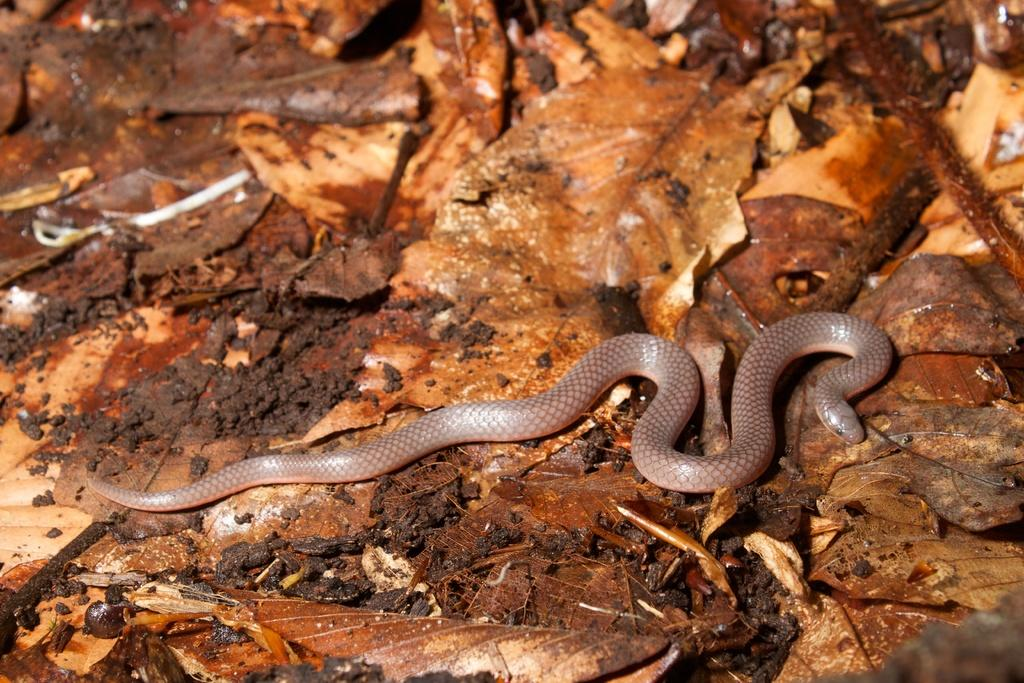What type of animal is in the image? There is a snake in the image. What else can be seen in the image besides the snake? There are leaves in the image. What type of tent can be seen in the image? There is no tent present in the image. What type of plant is the snake interacting with in the image? There is no plant or interaction with a plant depicted in the image. 